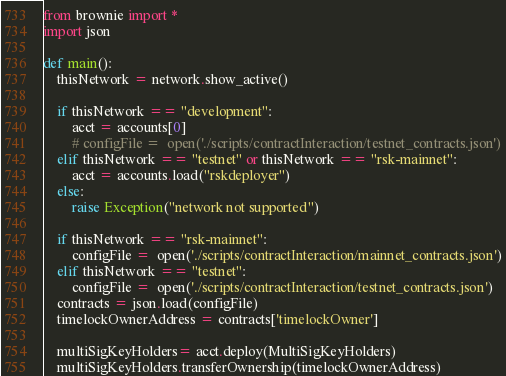<code> <loc_0><loc_0><loc_500><loc_500><_Python_>from brownie import *
import json

def main():
    thisNetwork = network.show_active()

    if thisNetwork == "development":
        acct = accounts[0]
        # configFile =  open('./scripts/contractInteraction/testnet_contracts.json')
    elif thisNetwork == "testnet" or thisNetwork == "rsk-mainnet":
        acct = accounts.load("rskdeployer")
    else:
        raise Exception("network not supported")
        
    if thisNetwork == "rsk-mainnet":
        configFile =  open('./scripts/contractInteraction/mainnet_contracts.json')
    elif thisNetwork == "testnet":
        configFile =  open('./scripts/contractInteraction/testnet_contracts.json')
    contracts = json.load(configFile)
    timelockOwnerAddress = contracts['timelockOwner']

    multiSigKeyHolders= acct.deploy(MultiSigKeyHolders)
    multiSigKeyHolders.transferOwnership(timelockOwnerAddress)
</code> 